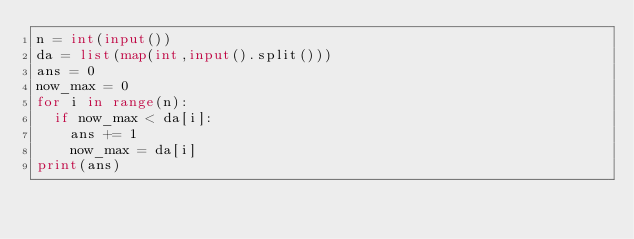<code> <loc_0><loc_0><loc_500><loc_500><_Python_>n = int(input())
da = list(map(int,input().split()))
ans = 0
now_max = 0
for i in range(n):
  if now_max < da[i]:
    ans += 1
    now_max = da[i]
print(ans)</code> 